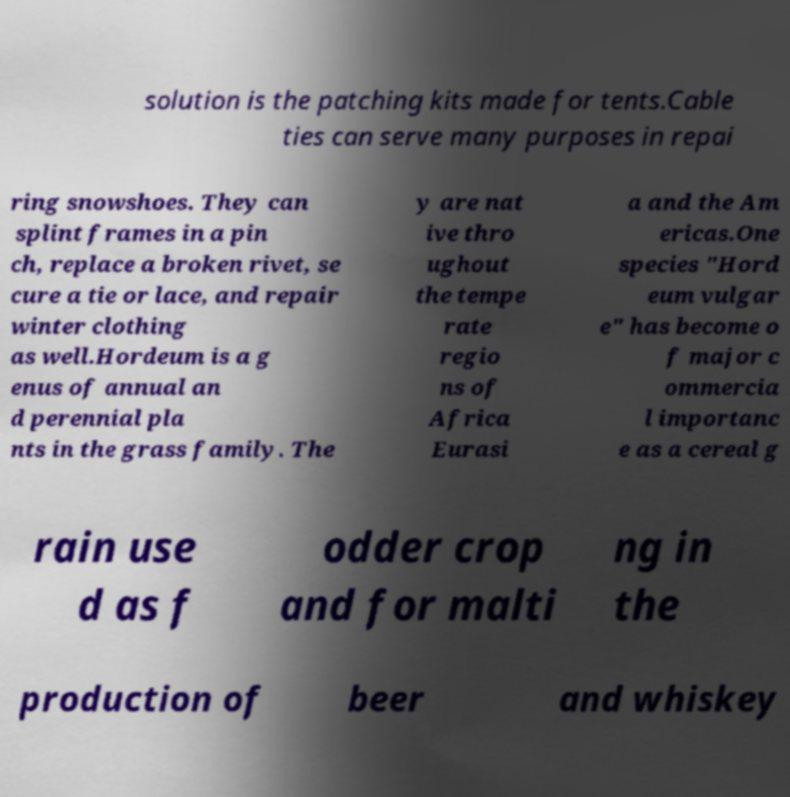Can you read and provide the text displayed in the image?This photo seems to have some interesting text. Can you extract and type it out for me? solution is the patching kits made for tents.Cable ties can serve many purposes in repai ring snowshoes. They can splint frames in a pin ch, replace a broken rivet, se cure a tie or lace, and repair winter clothing as well.Hordeum is a g enus of annual an d perennial pla nts in the grass family. The y are nat ive thro ughout the tempe rate regio ns of Africa Eurasi a and the Am ericas.One species "Hord eum vulgar e" has become o f major c ommercia l importanc e as a cereal g rain use d as f odder crop and for malti ng in the production of beer and whiskey 